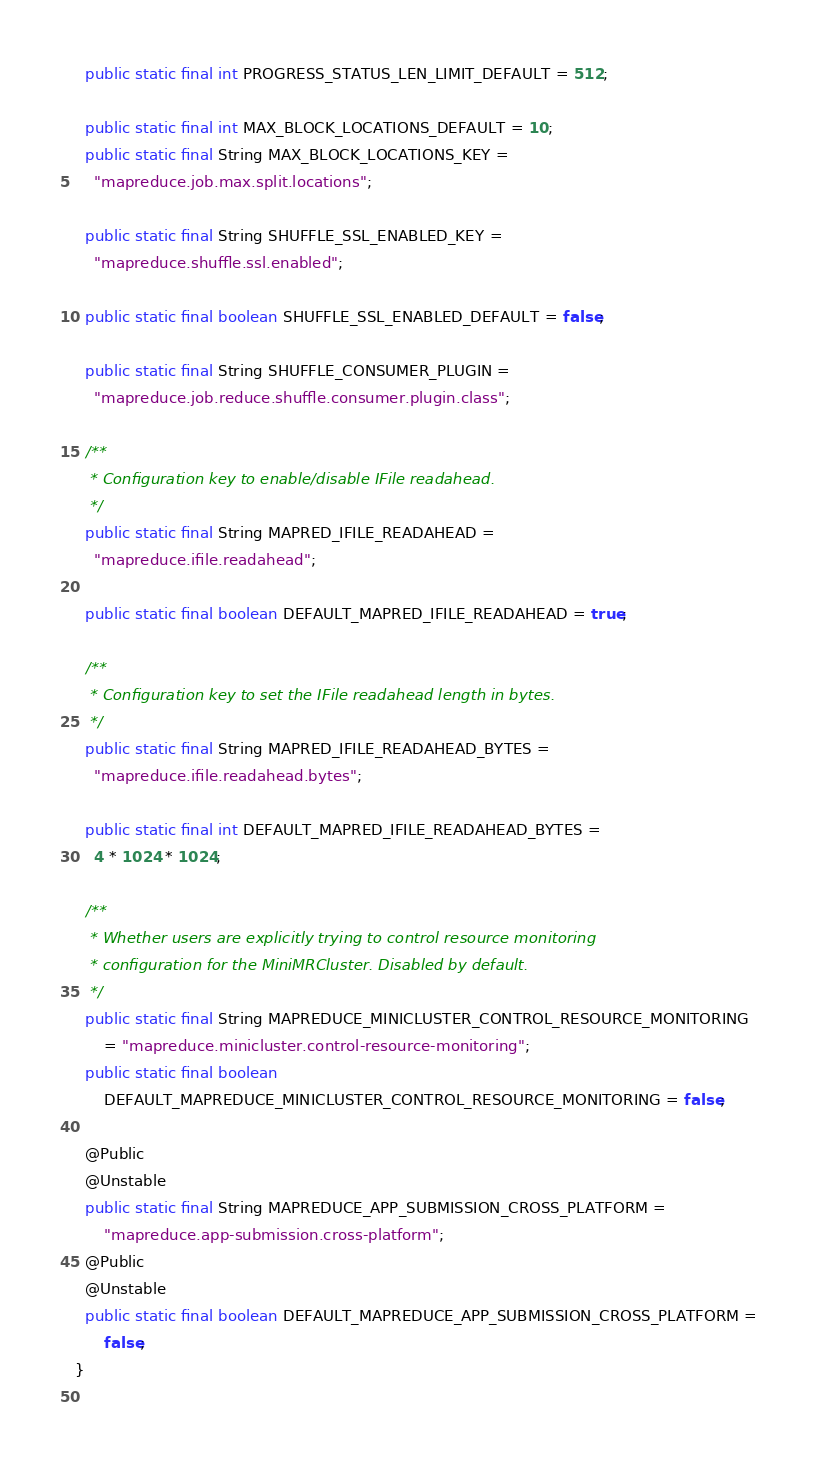Convert code to text. <code><loc_0><loc_0><loc_500><loc_500><_Java_>  public static final int PROGRESS_STATUS_LEN_LIMIT_DEFAULT = 512;

  public static final int MAX_BLOCK_LOCATIONS_DEFAULT = 10;
  public static final String MAX_BLOCK_LOCATIONS_KEY =
    "mapreduce.job.max.split.locations";

  public static final String SHUFFLE_SSL_ENABLED_KEY =
    "mapreduce.shuffle.ssl.enabled";

  public static final boolean SHUFFLE_SSL_ENABLED_DEFAULT = false;

  public static final String SHUFFLE_CONSUMER_PLUGIN =
    "mapreduce.job.reduce.shuffle.consumer.plugin.class";

  /**
   * Configuration key to enable/disable IFile readahead.
   */
  public static final String MAPRED_IFILE_READAHEAD =
    "mapreduce.ifile.readahead";

  public static final boolean DEFAULT_MAPRED_IFILE_READAHEAD = true;

  /**
   * Configuration key to set the IFile readahead length in bytes.
   */
  public static final String MAPRED_IFILE_READAHEAD_BYTES =
    "mapreduce.ifile.readahead.bytes";

  public static final int DEFAULT_MAPRED_IFILE_READAHEAD_BYTES =
    4 * 1024 * 1024;

  /**
   * Whether users are explicitly trying to control resource monitoring
   * configuration for the MiniMRCluster. Disabled by default.
   */
  public static final String MAPREDUCE_MINICLUSTER_CONTROL_RESOURCE_MONITORING
      = "mapreduce.minicluster.control-resource-monitoring";
  public static final boolean
      DEFAULT_MAPREDUCE_MINICLUSTER_CONTROL_RESOURCE_MONITORING = false;

  @Public
  @Unstable
  public static final String MAPREDUCE_APP_SUBMISSION_CROSS_PLATFORM =
      "mapreduce.app-submission.cross-platform";
  @Public
  @Unstable
  public static final boolean DEFAULT_MAPREDUCE_APP_SUBMISSION_CROSS_PLATFORM =
      false;
}
  
</code> 